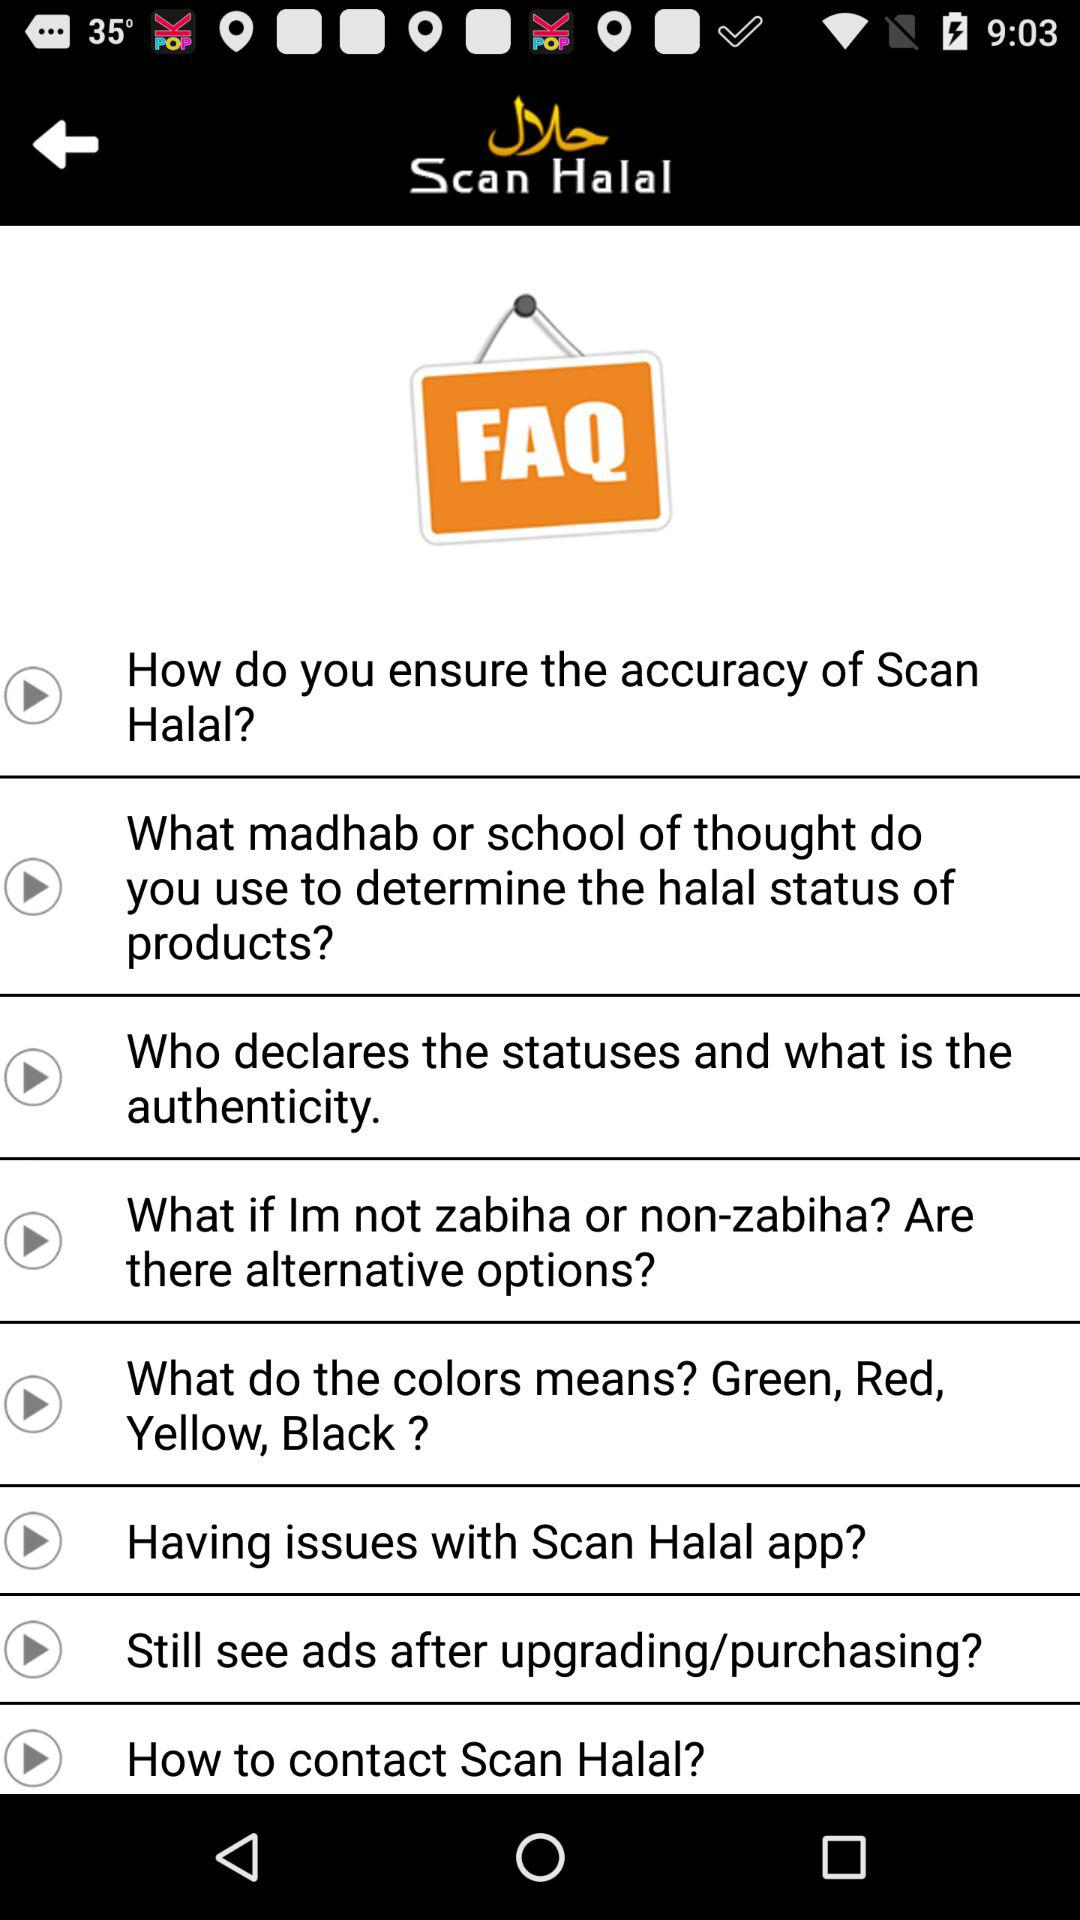What is the application name? The application name is "Scan Halal". 